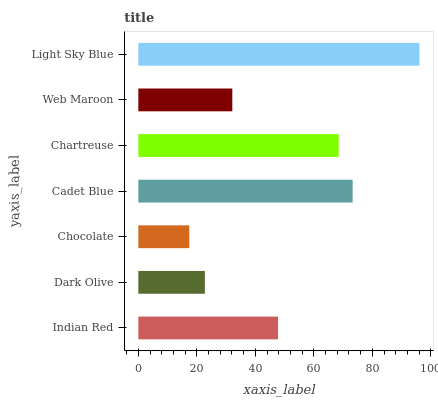Is Chocolate the minimum?
Answer yes or no. Yes. Is Light Sky Blue the maximum?
Answer yes or no. Yes. Is Dark Olive the minimum?
Answer yes or no. No. Is Dark Olive the maximum?
Answer yes or no. No. Is Indian Red greater than Dark Olive?
Answer yes or no. Yes. Is Dark Olive less than Indian Red?
Answer yes or no. Yes. Is Dark Olive greater than Indian Red?
Answer yes or no. No. Is Indian Red less than Dark Olive?
Answer yes or no. No. Is Indian Red the high median?
Answer yes or no. Yes. Is Indian Red the low median?
Answer yes or no. Yes. Is Light Sky Blue the high median?
Answer yes or no. No. Is Dark Olive the low median?
Answer yes or no. No. 